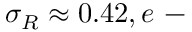Convert formula to latex. <formula><loc_0><loc_0><loc_500><loc_500>\sigma _ { R } \approx 0 . 4 2 , e -</formula> 